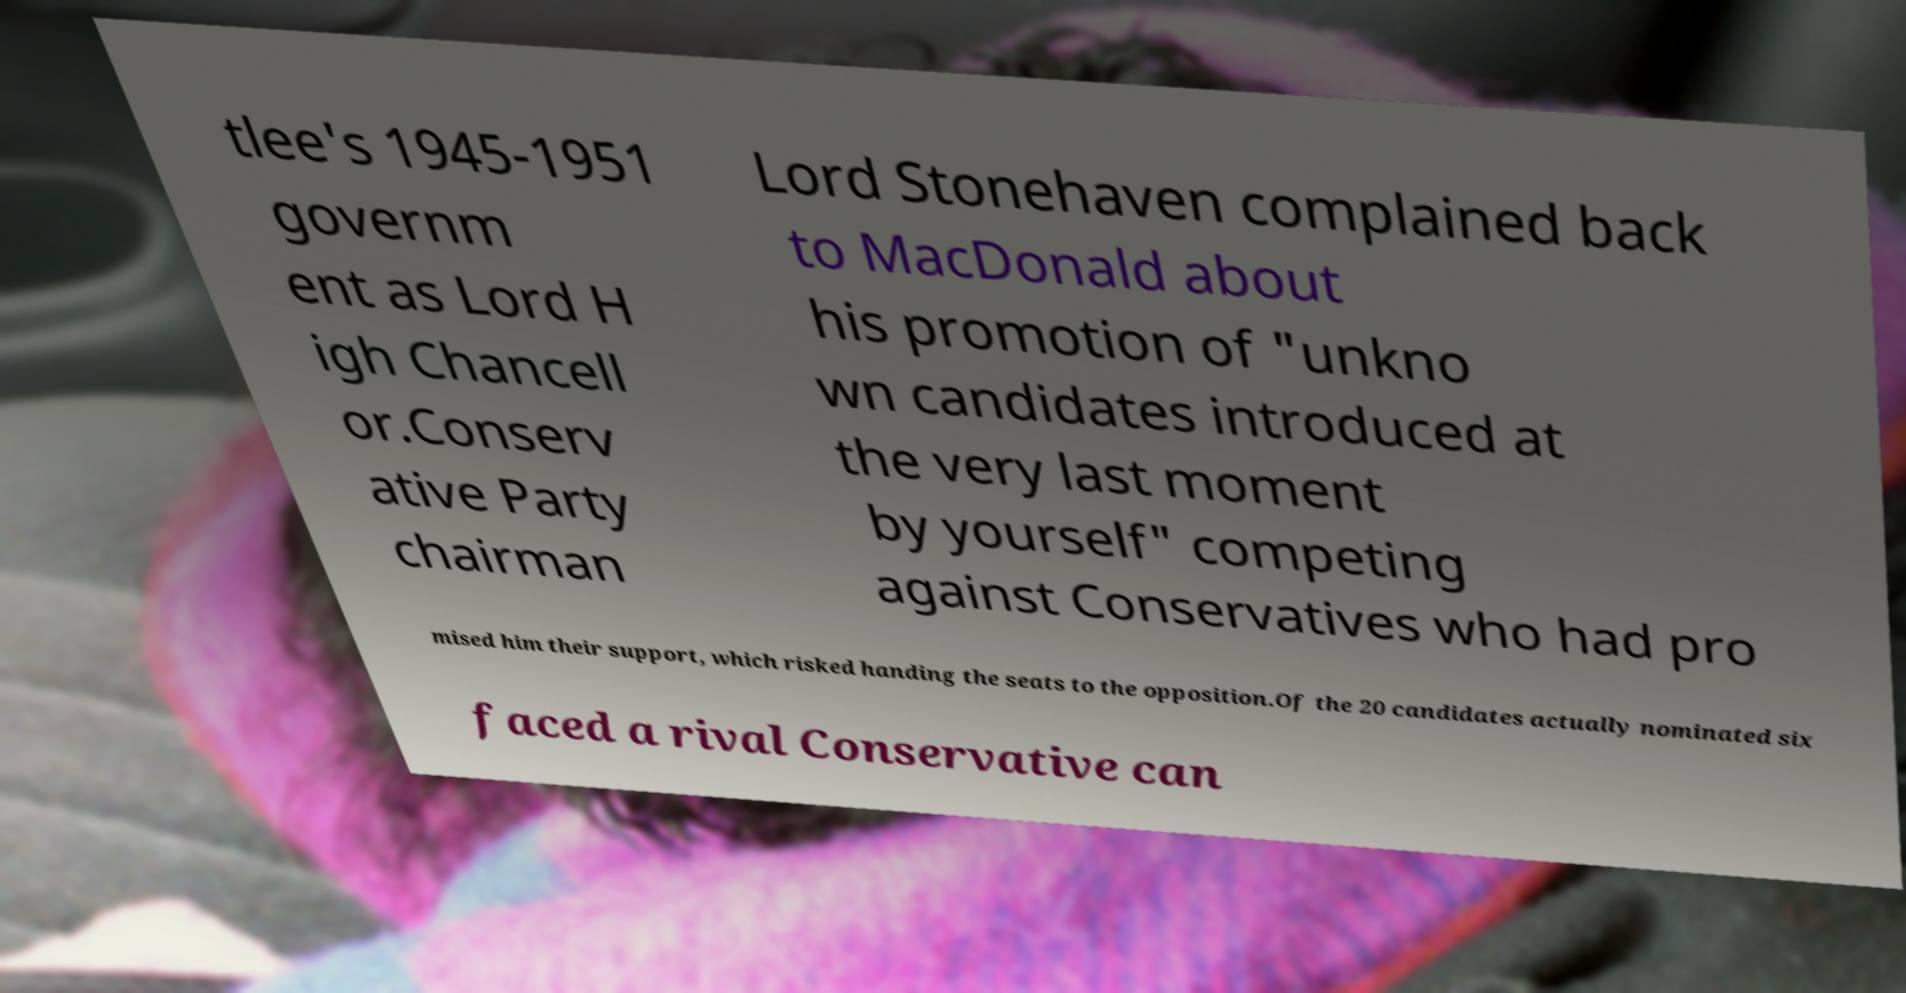Could you assist in decoding the text presented in this image and type it out clearly? tlee's 1945-1951 governm ent as Lord H igh Chancell or.Conserv ative Party chairman Lord Stonehaven complained back to MacDonald about his promotion of "unkno wn candidates introduced at the very last moment by yourself" competing against Conservatives who had pro mised him their support, which risked handing the seats to the opposition.Of the 20 candidates actually nominated six faced a rival Conservative can 